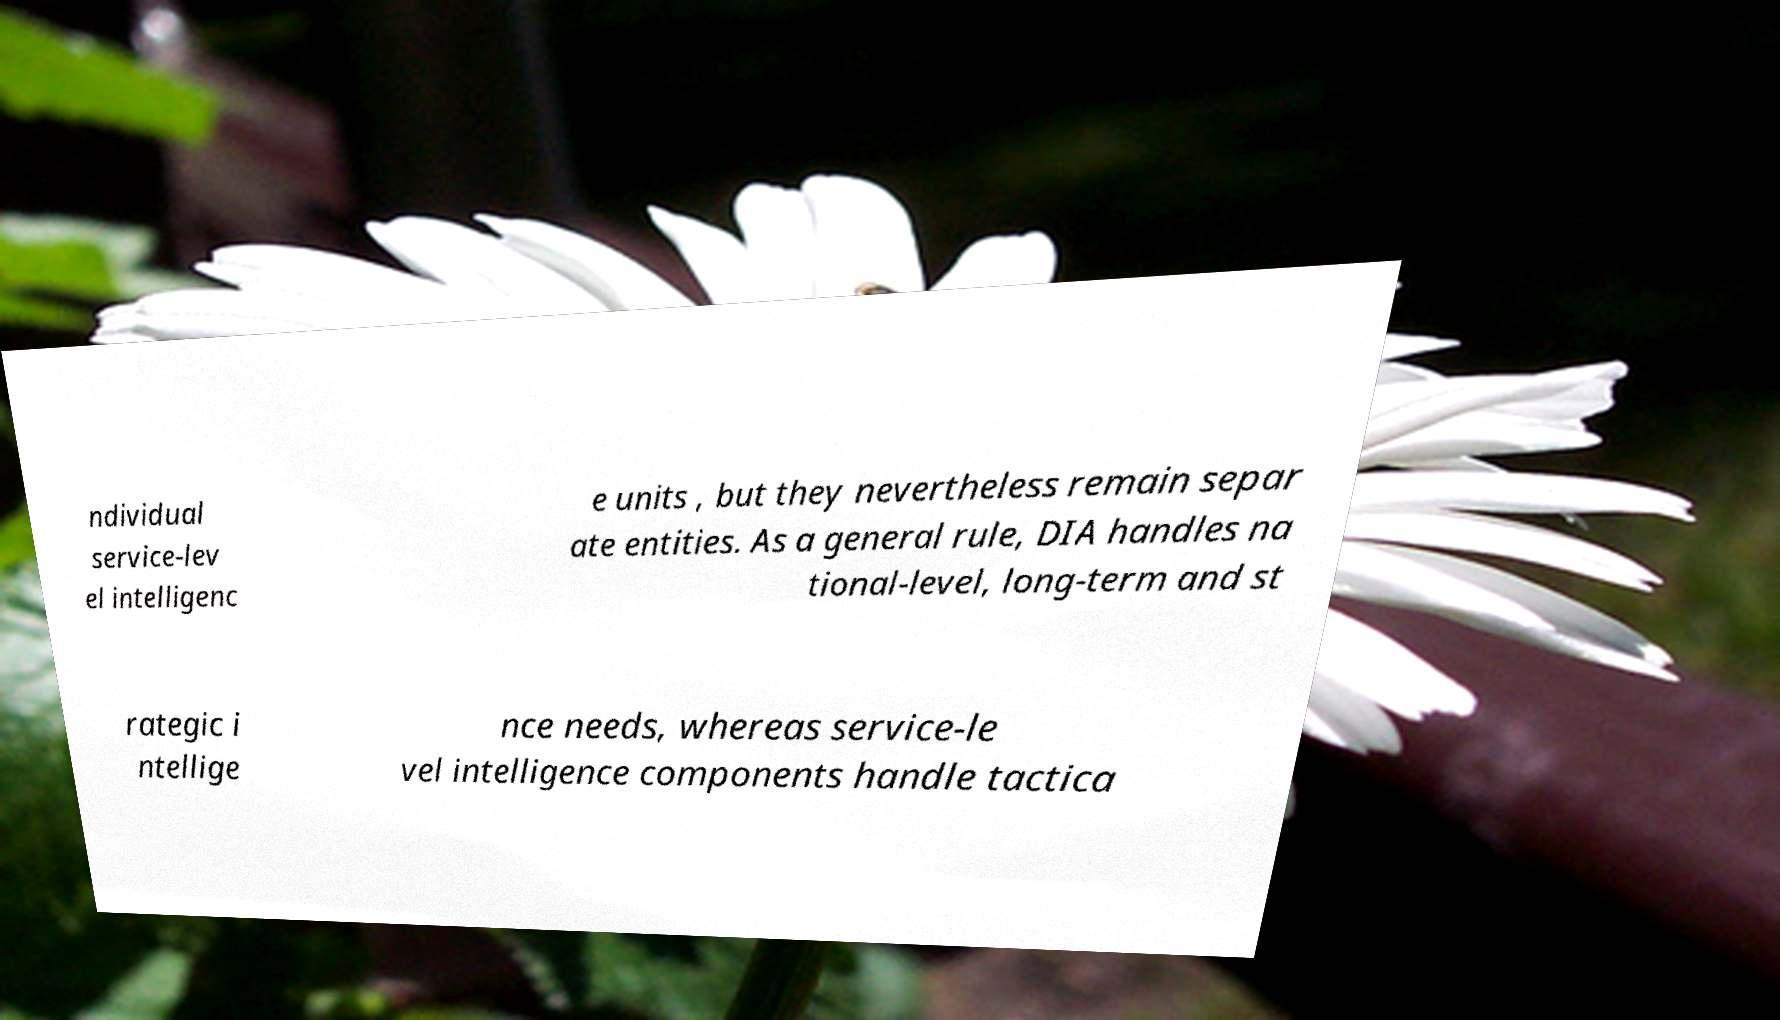Please read and relay the text visible in this image. What does it say? ndividual service-lev el intelligenc e units , but they nevertheless remain separ ate entities. As a general rule, DIA handles na tional-level, long-term and st rategic i ntellige nce needs, whereas service-le vel intelligence components handle tactica 